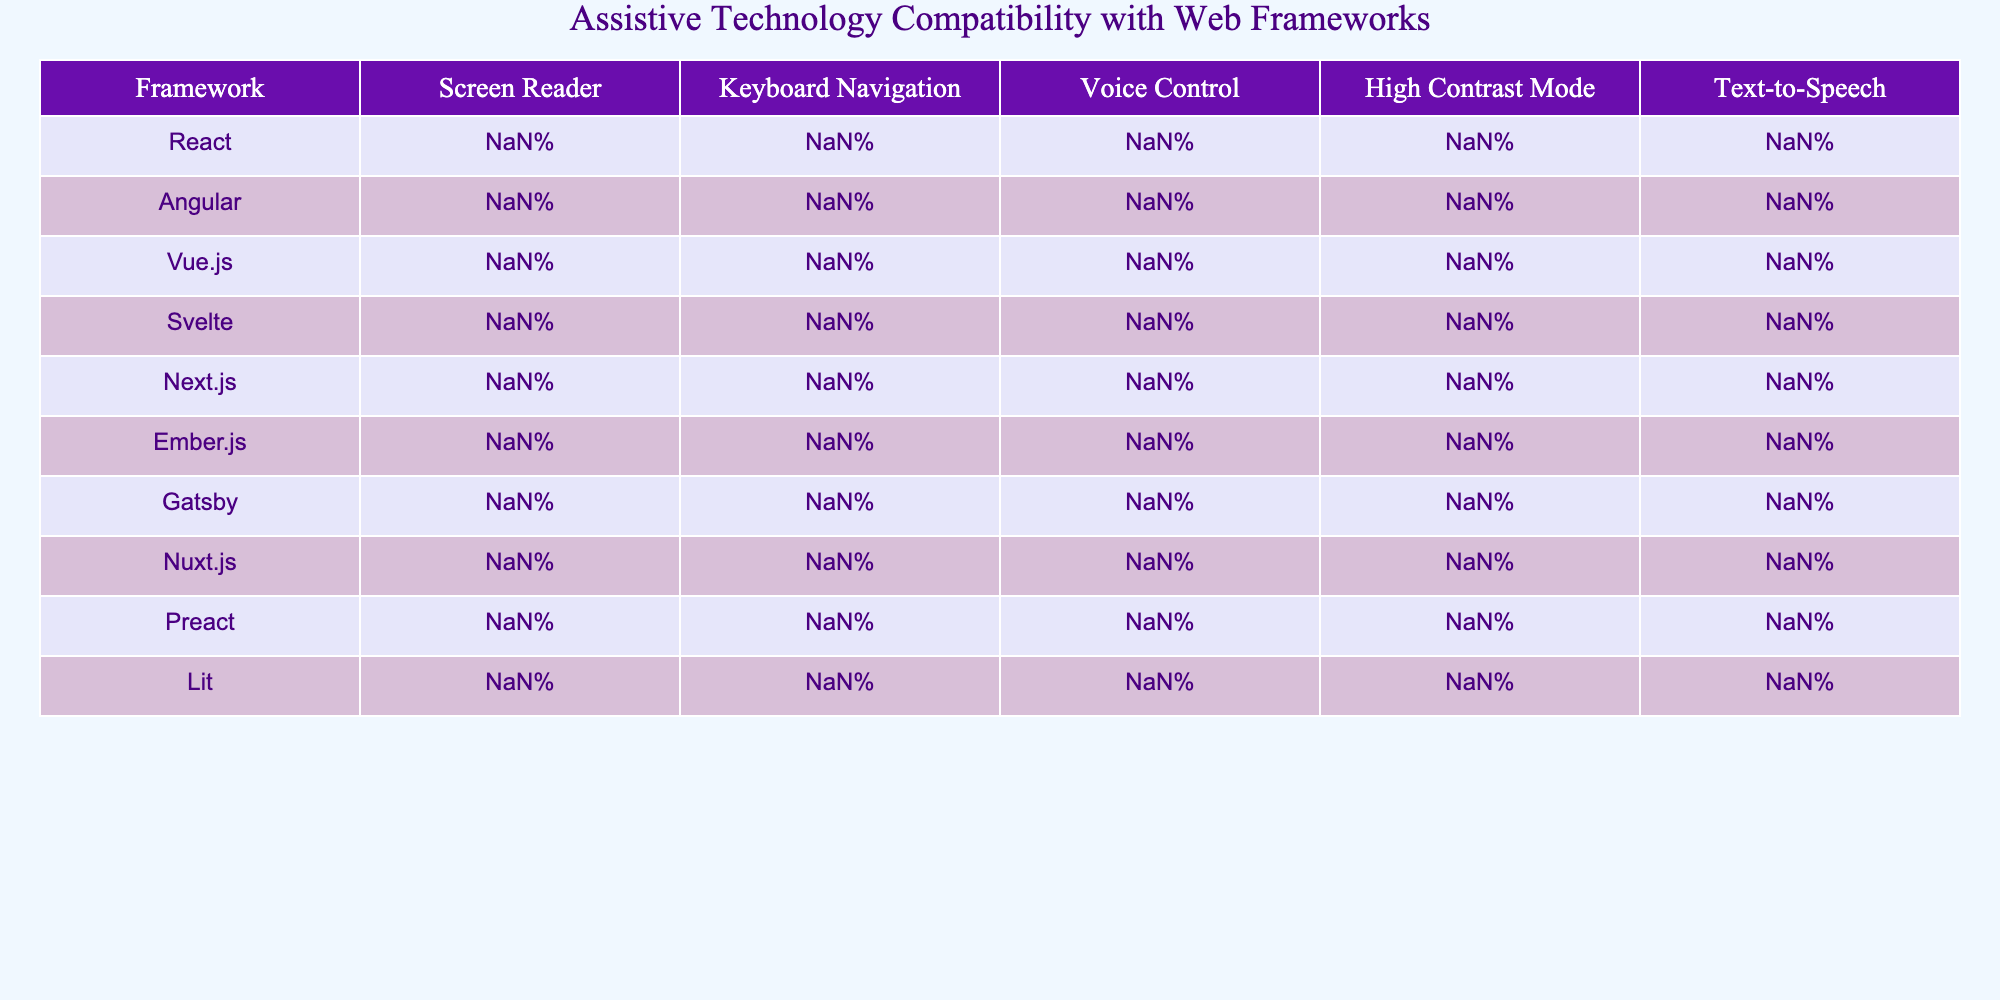What is the screen reader compatibility percentage for React? The table shows that React has a screen reader compatibility percentage of 90%.
Answer: 90% Which framework has the highest keyboard navigation compatibility? By looking at the table, React has the highest keyboard navigation compatibility at 95%.
Answer: React What is the average voice control compatibility across all frameworks? To find the average, I sum the voice control percentages (75% + 70% + 65% + 60% + 70% + 55% + 65% + 60% + 70% + 55%) =  670%. Since there are 10 frameworks, the average is 670% / 10 = 67%.
Answer: 67% Does Svelte have better high contrast mode compatibility than Vue.js? Svelte has a high contrast mode compatibility of 70%, while Vue.js has 75%. Since 70% is less than 75%, the statement is false.
Answer: No Which framework has the lowest text-to-speech compatibility? The table indicates that Ember.js has the lowest text-to-speech compatibility at 65%.
Answer: Ember.js If we compare Next.js and Preact for keyboard navigation, which one has a higher percentage and by how much? Next.js has 90% for keyboard navigation, and Preact has 90% as well. Since both values are equal, the difference is 0%.
Answer: 0% Are Angular’s high contrast mode and text-to-speech compatibilities above 80%? Angular's high contrast mode compatibility is 80%, and its text-to-speech compatibility is 85%. Both values are indeed above 80%, so the statement is true.
Answer: Yes Which framework has the highest overall compatibility? By analyzing all compatibility metrics for each framework, React consistently has the highest percentages in most categories, making it the highest overall compatible framework.
Answer: React Is there a framework where voice control compatibility is below 65%? The table shows that Svelte has a voice control compatibility of 60%, which is indeed below 65%.
Answer: Yes What is the difference in screen reader compatibility between Ember.js and Nuxt.js? Ember.js has a screen reader compatibility of 70%, while Nuxt.js has 75%. The difference is 75% - 70% = 5%.
Answer: 5% 